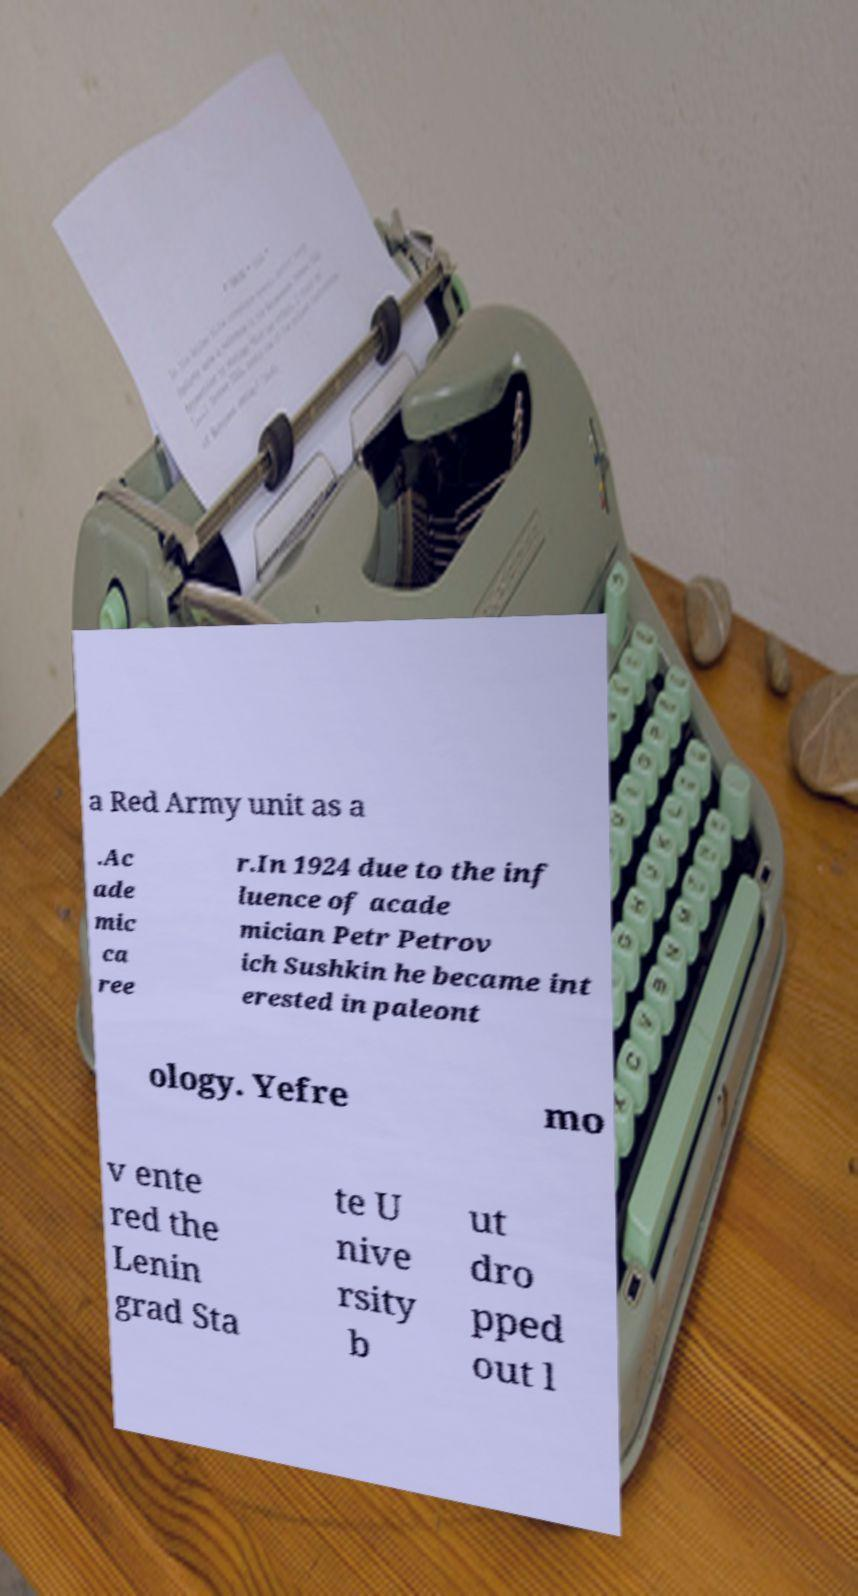Please read and relay the text visible in this image. What does it say? a Red Army unit as a .Ac ade mic ca ree r.In 1924 due to the inf luence of acade mician Petr Petrov ich Sushkin he became int erested in paleont ology. Yefre mo v ente red the Lenin grad Sta te U nive rsity b ut dro pped out l 